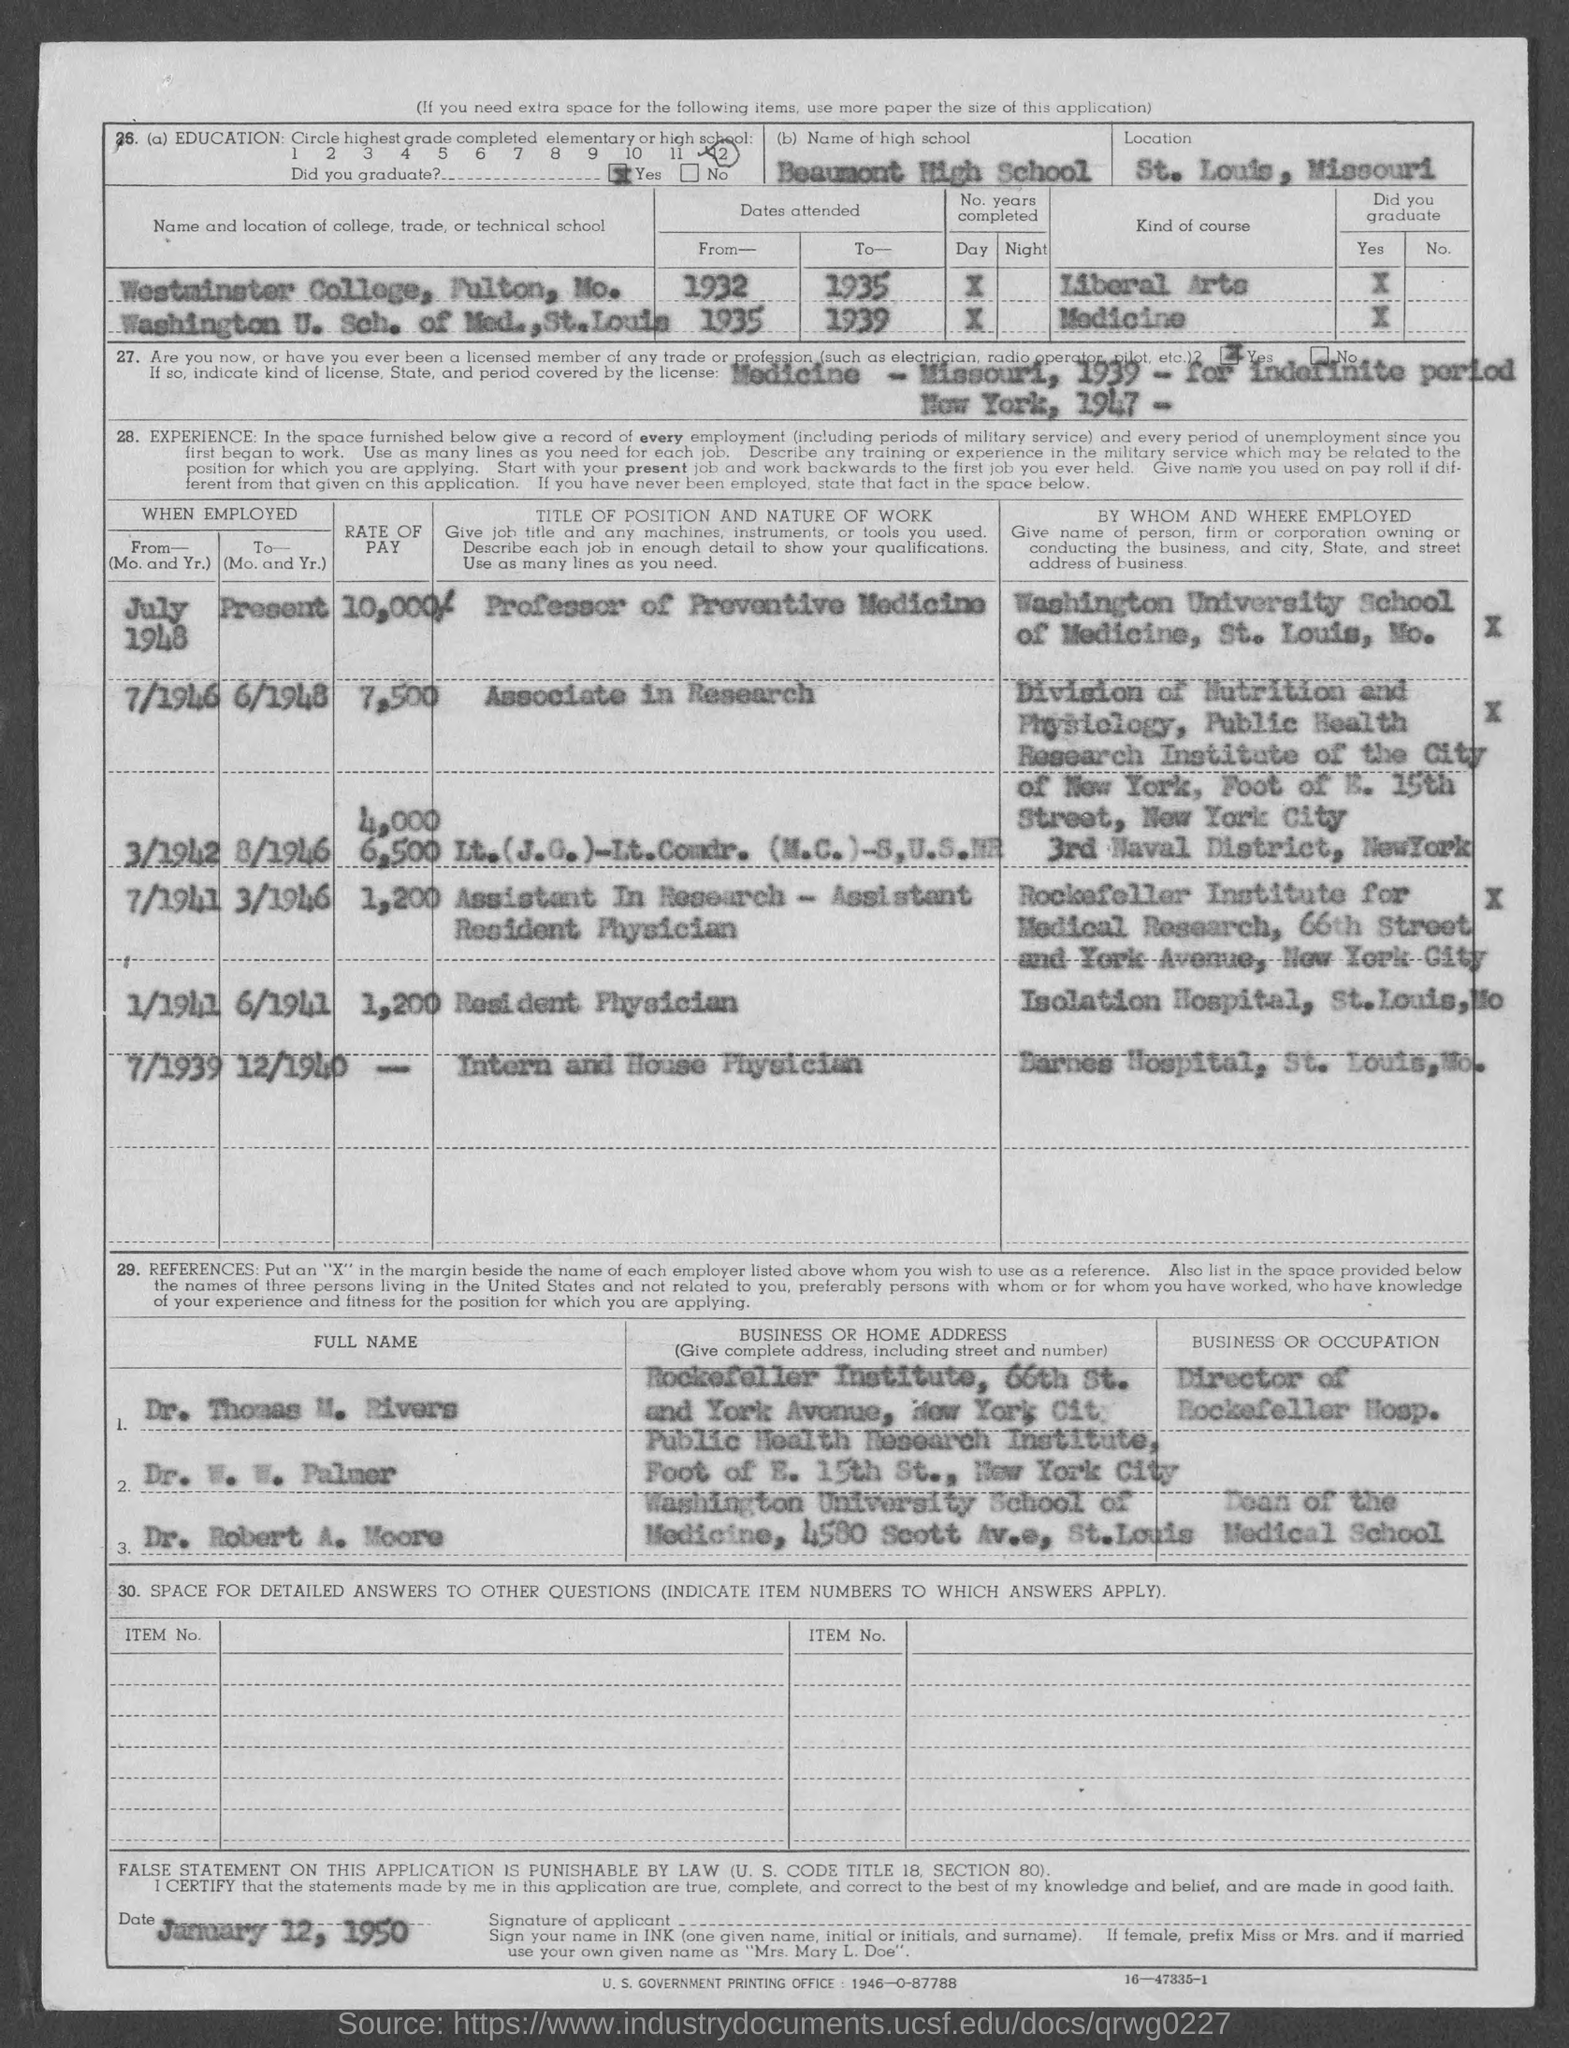What is the name of high school mentioned?
Provide a succinct answer. Beaumont High School. Which course was taken at Westminster College?
Keep it short and to the point. Liberal Arts. What is the rate of pay from July 1948 to present?
Your answer should be compact. 10,000/-. What was the title or position from 1/1946 to 6/1948?
Ensure brevity in your answer.  Associate in Research. Who is the Director of Rockefeller Hosp.?
Offer a very short reply. Dr. Thomas M. Rivers. What is the occupation of Dr. Robert A. Moore?
Keep it short and to the point. Dean of the Medical School. When is the document dated?
Your answer should be very brief. January 12, 1950. 